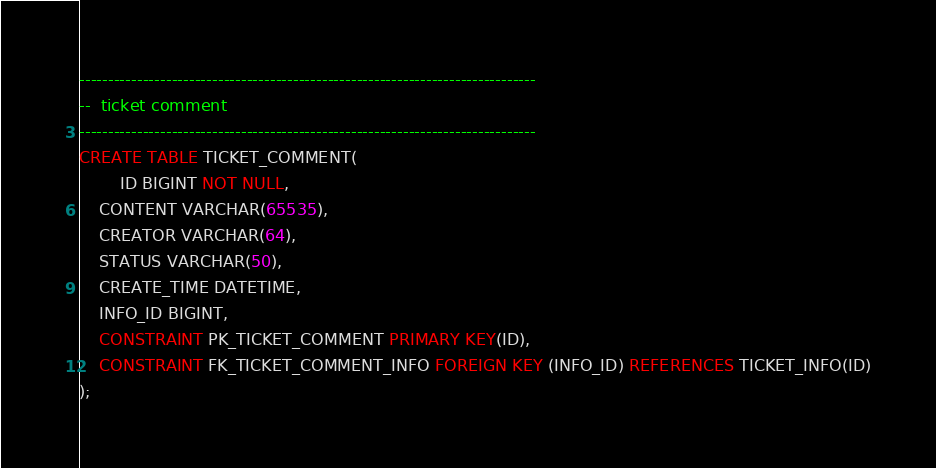Convert code to text. <code><loc_0><loc_0><loc_500><loc_500><_SQL_>

-------------------------------------------------------------------------------
--  ticket comment
-------------------------------------------------------------------------------
CREATE TABLE TICKET_COMMENT(
        ID BIGINT NOT NULL,
	CONTENT VARCHAR(65535),
	CREATOR VARCHAR(64),
	STATUS VARCHAR(50),
	CREATE_TIME DATETIME,
	INFO_ID BIGINT,
	CONSTRAINT PK_TICKET_COMMENT PRIMARY KEY(ID),
	CONSTRAINT FK_TICKET_COMMENT_INFO FOREIGN KEY (INFO_ID) REFERENCES TICKET_INFO(ID)
);

</code> 